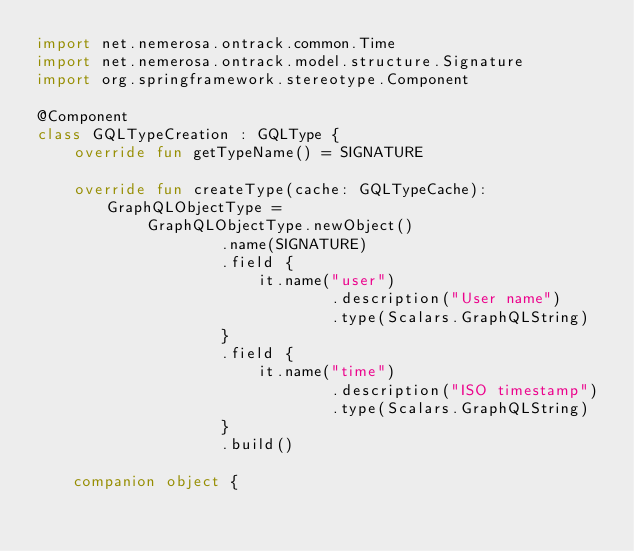<code> <loc_0><loc_0><loc_500><loc_500><_Kotlin_>import net.nemerosa.ontrack.common.Time
import net.nemerosa.ontrack.model.structure.Signature
import org.springframework.stereotype.Component

@Component
class GQLTypeCreation : GQLType {
    override fun getTypeName() = SIGNATURE

    override fun createType(cache: GQLTypeCache): GraphQLObjectType =
            GraphQLObjectType.newObject()
                    .name(SIGNATURE)
                    .field {
                        it.name("user")
                                .description("User name")
                                .type(Scalars.GraphQLString)
                    }
                    .field {
                        it.name("time")
                                .description("ISO timestamp")
                                .type(Scalars.GraphQLString)
                    }
                    .build()

    companion object {
</code> 